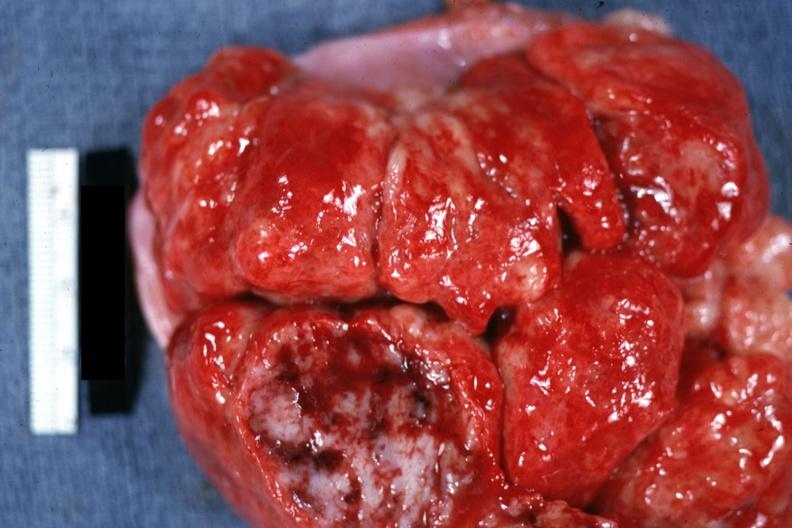how is massive enlargement with necrosis shown close-up color?
Answer the question using a single word or phrase. Natural 